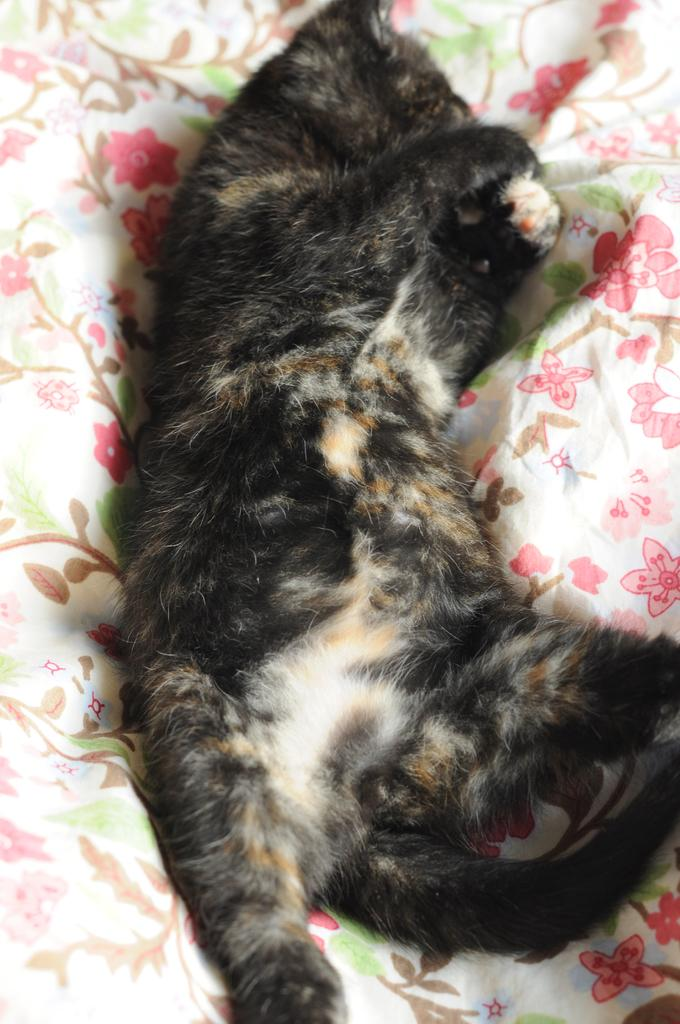What animal can be seen in the picture? There is a cat in the picture. Where is the cat located in the image? The cat is lying on the bed. What colors are present on the cat's fur? The cat is black and brown in color. What type of rule is the cat enforcing in the image? There is no rule being enforced in the image; it simply shows a cat lying on a bed. 